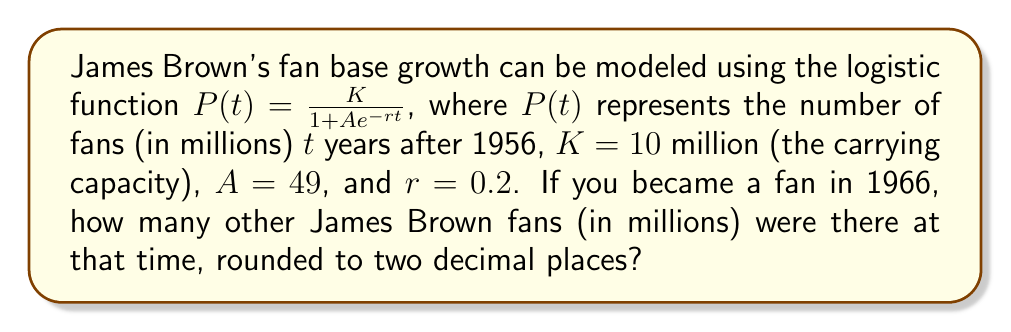Solve this math problem. To solve this problem, we need to follow these steps:

1. Identify the given parameters:
   $K = 10$ million (carrying capacity)
   $A = 49$
   $r = 0.2$
   $t = 10$ (since 1966 is 10 years after 1956)

2. Substitute these values into the logistic function:

   $$P(t) = \frac{K}{1 + Ae^{-rt}}$$

   $$P(10) = \frac{10}{1 + 49e^{-0.2(10)}}$$

3. Simplify the expression in the exponent:
   
   $$P(10) = \frac{10}{1 + 49e^{-2}}$$

4. Calculate $e^{-2}$ (you can use a calculator for this):
   
   $$e^{-2} \approx 0.1353$$

5. Substitute this value:

   $$P(10) = \frac{10}{1 + 49(0.1353)}$$

6. Simplify:

   $$P(10) = \frac{10}{1 + 6.6297}$$
   $$P(10) = \frac{10}{7.6297}$$

7. Divide:

   $$P(10) \approx 1.3106$$

8. Round to two decimal places:

   $$P(10) \approx 1.31$$

Therefore, in 1966, there were approximately 1.31 million James Brown fans.
Answer: 1.31 million 